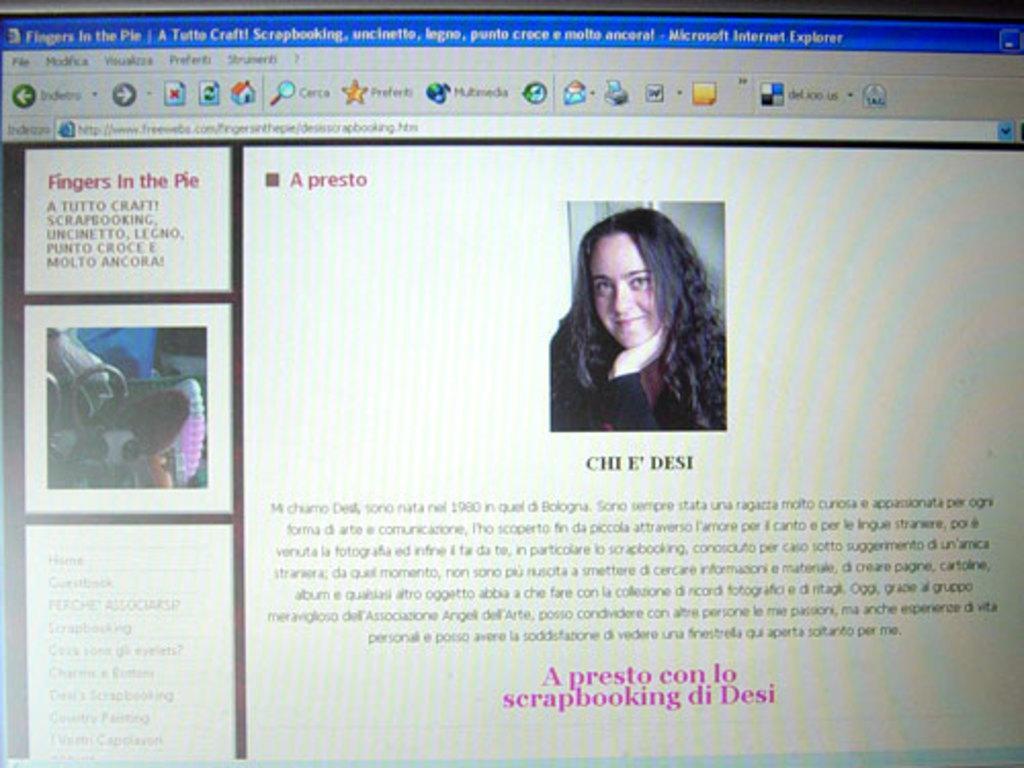Could you give a brief overview of what you see in this image? In this image, we can see a web page contains pictures and some text. There is an address bar and toolbar at the top of the image. 